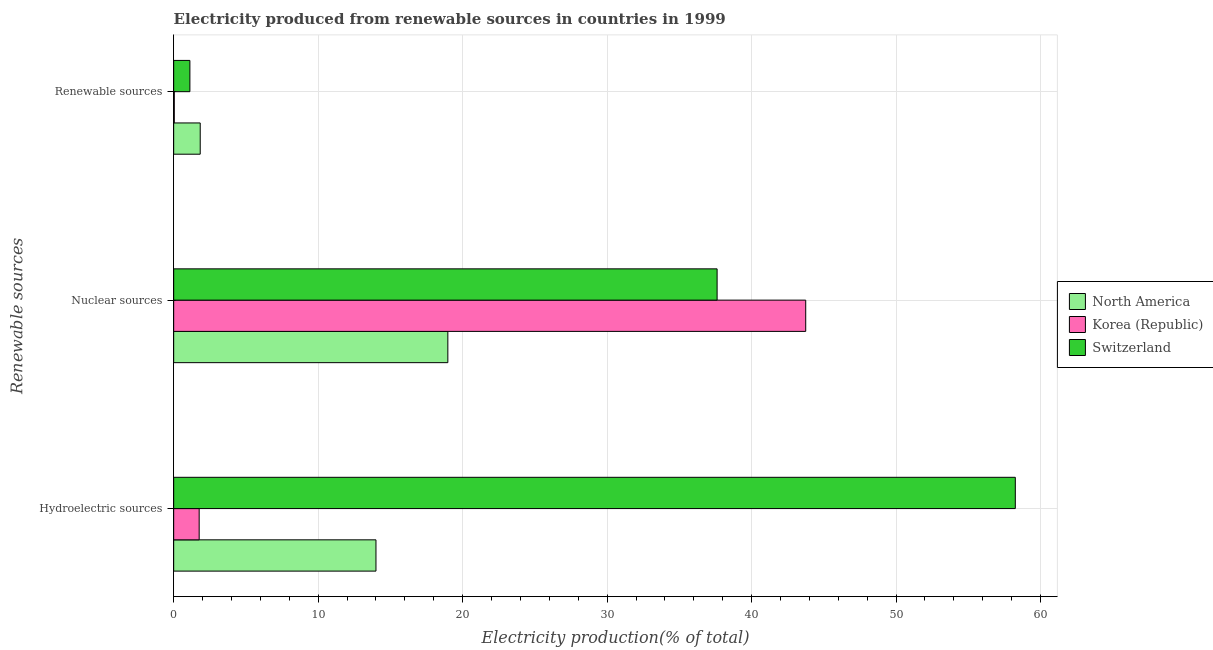How many different coloured bars are there?
Give a very brief answer. 3. How many bars are there on the 3rd tick from the top?
Provide a succinct answer. 3. How many bars are there on the 3rd tick from the bottom?
Provide a succinct answer. 3. What is the label of the 1st group of bars from the top?
Your answer should be compact. Renewable sources. What is the percentage of electricity produced by renewable sources in Switzerland?
Offer a very short reply. 1.12. Across all countries, what is the maximum percentage of electricity produced by hydroelectric sources?
Provide a short and direct response. 58.25. Across all countries, what is the minimum percentage of electricity produced by hydroelectric sources?
Offer a very short reply. 1.77. In which country was the percentage of electricity produced by hydroelectric sources maximum?
Ensure brevity in your answer.  Switzerland. What is the total percentage of electricity produced by hydroelectric sources in the graph?
Your answer should be very brief. 74.02. What is the difference between the percentage of electricity produced by nuclear sources in North America and that in Switzerland?
Keep it short and to the point. -18.64. What is the difference between the percentage of electricity produced by renewable sources in North America and the percentage of electricity produced by nuclear sources in Korea (Republic)?
Make the answer very short. -41.91. What is the average percentage of electricity produced by hydroelectric sources per country?
Provide a succinct answer. 24.67. What is the difference between the percentage of electricity produced by hydroelectric sources and percentage of electricity produced by renewable sources in Switzerland?
Give a very brief answer. 57.13. In how many countries, is the percentage of electricity produced by hydroelectric sources greater than 10 %?
Keep it short and to the point. 2. What is the ratio of the percentage of electricity produced by renewable sources in Korea (Republic) to that in Switzerland?
Give a very brief answer. 0.04. Is the difference between the percentage of electricity produced by renewable sources in Korea (Republic) and Switzerland greater than the difference between the percentage of electricity produced by hydroelectric sources in Korea (Republic) and Switzerland?
Keep it short and to the point. Yes. What is the difference between the highest and the second highest percentage of electricity produced by nuclear sources?
Ensure brevity in your answer.  6.13. What is the difference between the highest and the lowest percentage of electricity produced by renewable sources?
Offer a terse response. 1.8. In how many countries, is the percentage of electricity produced by nuclear sources greater than the average percentage of electricity produced by nuclear sources taken over all countries?
Your answer should be very brief. 2. Is the sum of the percentage of electricity produced by nuclear sources in North America and Korea (Republic) greater than the maximum percentage of electricity produced by hydroelectric sources across all countries?
Offer a very short reply. Yes. What does the 1st bar from the top in Nuclear sources represents?
Your answer should be very brief. Switzerland. What does the 3rd bar from the bottom in Renewable sources represents?
Your answer should be compact. Switzerland. Is it the case that in every country, the sum of the percentage of electricity produced by hydroelectric sources and percentage of electricity produced by nuclear sources is greater than the percentage of electricity produced by renewable sources?
Give a very brief answer. Yes. How many bars are there?
Your answer should be compact. 9. Are all the bars in the graph horizontal?
Provide a short and direct response. Yes. What is the difference between two consecutive major ticks on the X-axis?
Make the answer very short. 10. Are the values on the major ticks of X-axis written in scientific E-notation?
Your answer should be very brief. No. Does the graph contain any zero values?
Provide a succinct answer. No. Does the graph contain grids?
Give a very brief answer. Yes. How many legend labels are there?
Ensure brevity in your answer.  3. How are the legend labels stacked?
Your response must be concise. Vertical. What is the title of the graph?
Your answer should be very brief. Electricity produced from renewable sources in countries in 1999. Does "Kosovo" appear as one of the legend labels in the graph?
Offer a very short reply. No. What is the label or title of the X-axis?
Provide a succinct answer. Electricity production(% of total). What is the label or title of the Y-axis?
Keep it short and to the point. Renewable sources. What is the Electricity production(% of total) in North America in Hydroelectric sources?
Provide a succinct answer. 14. What is the Electricity production(% of total) in Korea (Republic) in Hydroelectric sources?
Your answer should be compact. 1.77. What is the Electricity production(% of total) of Switzerland in Hydroelectric sources?
Your answer should be very brief. 58.25. What is the Electricity production(% of total) of North America in Nuclear sources?
Keep it short and to the point. 18.98. What is the Electricity production(% of total) in Korea (Republic) in Nuclear sources?
Offer a very short reply. 43.75. What is the Electricity production(% of total) of Switzerland in Nuclear sources?
Make the answer very short. 37.61. What is the Electricity production(% of total) of North America in Renewable sources?
Give a very brief answer. 1.84. What is the Electricity production(% of total) in Korea (Republic) in Renewable sources?
Your answer should be very brief. 0.04. What is the Electricity production(% of total) of Switzerland in Renewable sources?
Provide a short and direct response. 1.12. Across all Renewable sources, what is the maximum Electricity production(% of total) of North America?
Keep it short and to the point. 18.98. Across all Renewable sources, what is the maximum Electricity production(% of total) in Korea (Republic)?
Offer a terse response. 43.75. Across all Renewable sources, what is the maximum Electricity production(% of total) in Switzerland?
Offer a terse response. 58.25. Across all Renewable sources, what is the minimum Electricity production(% of total) in North America?
Offer a terse response. 1.84. Across all Renewable sources, what is the minimum Electricity production(% of total) in Korea (Republic)?
Your answer should be very brief. 0.04. Across all Renewable sources, what is the minimum Electricity production(% of total) of Switzerland?
Your answer should be very brief. 1.12. What is the total Electricity production(% of total) of North America in the graph?
Keep it short and to the point. 34.82. What is the total Electricity production(% of total) in Korea (Republic) in the graph?
Ensure brevity in your answer.  45.55. What is the total Electricity production(% of total) in Switzerland in the graph?
Provide a succinct answer. 96.99. What is the difference between the Electricity production(% of total) of North America in Hydroelectric sources and that in Nuclear sources?
Provide a short and direct response. -4.98. What is the difference between the Electricity production(% of total) of Korea (Republic) in Hydroelectric sources and that in Nuclear sources?
Provide a short and direct response. -41.98. What is the difference between the Electricity production(% of total) in Switzerland in Hydroelectric sources and that in Nuclear sources?
Your answer should be very brief. 20.64. What is the difference between the Electricity production(% of total) in North America in Hydroelectric sources and that in Renewable sources?
Offer a very short reply. 12.16. What is the difference between the Electricity production(% of total) of Korea (Republic) in Hydroelectric sources and that in Renewable sources?
Offer a terse response. 1.72. What is the difference between the Electricity production(% of total) in Switzerland in Hydroelectric sources and that in Renewable sources?
Provide a succinct answer. 57.13. What is the difference between the Electricity production(% of total) of North America in Nuclear sources and that in Renewable sources?
Offer a very short reply. 17.14. What is the difference between the Electricity production(% of total) in Korea (Republic) in Nuclear sources and that in Renewable sources?
Offer a very short reply. 43.7. What is the difference between the Electricity production(% of total) in Switzerland in Nuclear sources and that in Renewable sources?
Provide a short and direct response. 36.49. What is the difference between the Electricity production(% of total) of North America in Hydroelectric sources and the Electricity production(% of total) of Korea (Republic) in Nuclear sources?
Keep it short and to the point. -29.74. What is the difference between the Electricity production(% of total) in North America in Hydroelectric sources and the Electricity production(% of total) in Switzerland in Nuclear sources?
Offer a very short reply. -23.61. What is the difference between the Electricity production(% of total) in Korea (Republic) in Hydroelectric sources and the Electricity production(% of total) in Switzerland in Nuclear sources?
Offer a terse response. -35.85. What is the difference between the Electricity production(% of total) in North America in Hydroelectric sources and the Electricity production(% of total) in Korea (Republic) in Renewable sources?
Provide a short and direct response. 13.96. What is the difference between the Electricity production(% of total) of North America in Hydroelectric sources and the Electricity production(% of total) of Switzerland in Renewable sources?
Your answer should be compact. 12.88. What is the difference between the Electricity production(% of total) in Korea (Republic) in Hydroelectric sources and the Electricity production(% of total) in Switzerland in Renewable sources?
Offer a very short reply. 0.64. What is the difference between the Electricity production(% of total) of North America in Nuclear sources and the Electricity production(% of total) of Korea (Republic) in Renewable sources?
Offer a very short reply. 18.93. What is the difference between the Electricity production(% of total) of North America in Nuclear sources and the Electricity production(% of total) of Switzerland in Renewable sources?
Keep it short and to the point. 17.85. What is the difference between the Electricity production(% of total) of Korea (Republic) in Nuclear sources and the Electricity production(% of total) of Switzerland in Renewable sources?
Provide a succinct answer. 42.62. What is the average Electricity production(% of total) in North America per Renewable sources?
Your answer should be compact. 11.61. What is the average Electricity production(% of total) of Korea (Republic) per Renewable sources?
Offer a terse response. 15.18. What is the average Electricity production(% of total) of Switzerland per Renewable sources?
Ensure brevity in your answer.  32.33. What is the difference between the Electricity production(% of total) of North America and Electricity production(% of total) of Korea (Republic) in Hydroelectric sources?
Offer a very short reply. 12.24. What is the difference between the Electricity production(% of total) in North America and Electricity production(% of total) in Switzerland in Hydroelectric sources?
Keep it short and to the point. -44.25. What is the difference between the Electricity production(% of total) in Korea (Republic) and Electricity production(% of total) in Switzerland in Hydroelectric sources?
Offer a very short reply. -56.49. What is the difference between the Electricity production(% of total) of North America and Electricity production(% of total) of Korea (Republic) in Nuclear sources?
Provide a succinct answer. -24.77. What is the difference between the Electricity production(% of total) in North America and Electricity production(% of total) in Switzerland in Nuclear sources?
Make the answer very short. -18.64. What is the difference between the Electricity production(% of total) in Korea (Republic) and Electricity production(% of total) in Switzerland in Nuclear sources?
Keep it short and to the point. 6.13. What is the difference between the Electricity production(% of total) in North America and Electricity production(% of total) in Korea (Republic) in Renewable sources?
Your response must be concise. 1.8. What is the difference between the Electricity production(% of total) of North America and Electricity production(% of total) of Switzerland in Renewable sources?
Make the answer very short. 0.71. What is the difference between the Electricity production(% of total) in Korea (Republic) and Electricity production(% of total) in Switzerland in Renewable sources?
Offer a very short reply. -1.08. What is the ratio of the Electricity production(% of total) in North America in Hydroelectric sources to that in Nuclear sources?
Provide a short and direct response. 0.74. What is the ratio of the Electricity production(% of total) in Korea (Republic) in Hydroelectric sources to that in Nuclear sources?
Keep it short and to the point. 0.04. What is the ratio of the Electricity production(% of total) of Switzerland in Hydroelectric sources to that in Nuclear sources?
Keep it short and to the point. 1.55. What is the ratio of the Electricity production(% of total) of North America in Hydroelectric sources to that in Renewable sources?
Offer a terse response. 7.62. What is the ratio of the Electricity production(% of total) in Korea (Republic) in Hydroelectric sources to that in Renewable sources?
Your response must be concise. 42.44. What is the ratio of the Electricity production(% of total) in Switzerland in Hydroelectric sources to that in Renewable sources?
Provide a succinct answer. 51.89. What is the ratio of the Electricity production(% of total) in North America in Nuclear sources to that in Renewable sources?
Offer a terse response. 10.33. What is the ratio of the Electricity production(% of total) in Korea (Republic) in Nuclear sources to that in Renewable sources?
Provide a short and direct response. 1051.67. What is the ratio of the Electricity production(% of total) in Switzerland in Nuclear sources to that in Renewable sources?
Your response must be concise. 33.5. What is the difference between the highest and the second highest Electricity production(% of total) of North America?
Provide a succinct answer. 4.98. What is the difference between the highest and the second highest Electricity production(% of total) of Korea (Republic)?
Your answer should be compact. 41.98. What is the difference between the highest and the second highest Electricity production(% of total) in Switzerland?
Provide a succinct answer. 20.64. What is the difference between the highest and the lowest Electricity production(% of total) of North America?
Offer a terse response. 17.14. What is the difference between the highest and the lowest Electricity production(% of total) in Korea (Republic)?
Your response must be concise. 43.7. What is the difference between the highest and the lowest Electricity production(% of total) of Switzerland?
Your answer should be very brief. 57.13. 